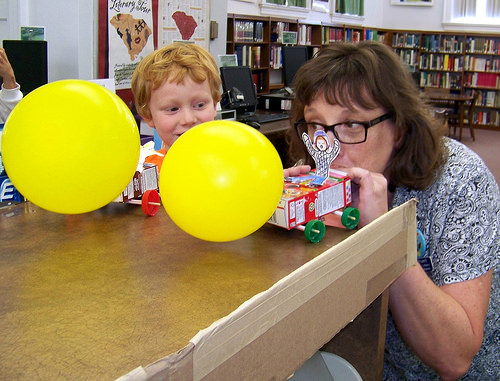<image>
Is the woman to the left of the child? No. The woman is not to the left of the child. From this viewpoint, they have a different horizontal relationship. 